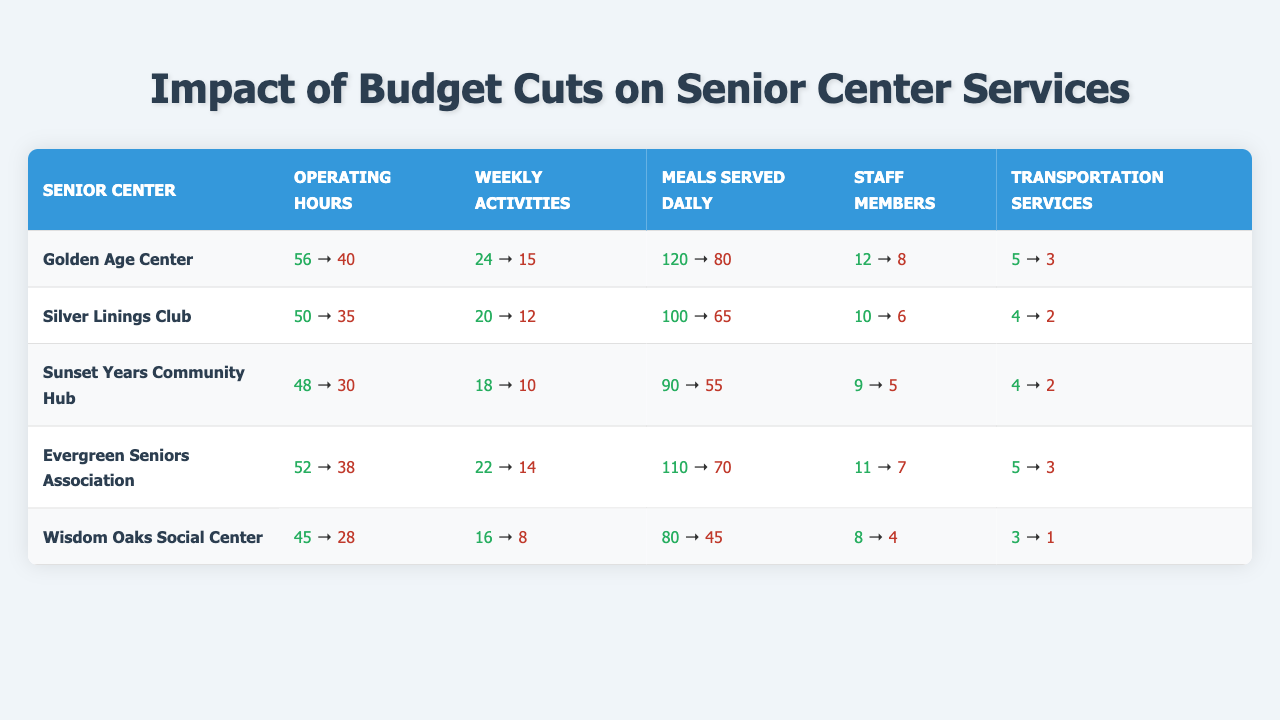What were the operating hours at the Golden Age Center before the budget cuts? The table lists the operating hours for the Golden Age Center as 56 hours before the budget cuts.
Answer: 56 How many meals were served daily at the Silver Linings Club after the budget cuts? According to the table, the number of meals served daily at the Silver Linings Club after the budget cuts is 65.
Answer: 65 What is the total reduction in weekly activities for the Sunset Years Community Hub due to budget cuts? Before the budget cuts, the Sunset Years Community Hub had 18 weekly activities, and after the cuts, it has 10. The reduction is calculated as 18 - 10 = 8.
Answer: 8 Did Evergreen Seniors Association serve more meals daily before or after the budget cuts? The Evergreen Seniors Association served 110 meals daily before the budget cuts and 70 meals after. Since 110 is greater than 70, they served more meals before the cuts.
Answer: Yes What are the differences in staff members before and after the budget cuts across all senior centers? For each center, we can find the difference: Golden Age Center (12 - 8 = 4), Silver Linings Club (10 - 6 = 4), Sunset Years Community Hub (9 - 5 = 4), Evergreen Seniors Association (11 - 7 = 4), and Wisdom Oaks Social Center (8 - 4 = 4). All Centers had a reduction of 4 staff members.
Answer: 4 Which senior center had the lowest operating hours after the budget cuts, and what were those hours? After the budget cuts, Wisdom Oaks Social Center had the lowest operating hours of 28.
Answer: Wisdom Oaks Social Center, 28 What is the overall average operating hours of all senior centers before the budget cuts? The total operating hours before cuts is (56 + 50 + 48 + 52 + 45) = 251, and there are 5 centers, so the average is 251 / 5 = 50.2.
Answer: 50.2 Which senior center experienced the highest percentage drop in transportation services after the budget cuts? Transportation services before and after cuts: Golden Age Center (5 to 3, 40% drop), Silver Linings Club (4 to 2, 50% drop), Sunset Years Community Hub (4 to 2, 50% drop), Evergreen Seniors Association (5 to 3, 40% drop), and Wisdom Oaks Social Center (3 to 1, 66.67% drop). The highest percentage drop is for Wisdom Oaks Social Center.
Answer: Wisdom Oaks Social Center What is the total number of meals served daily across all centers before budget cuts compared to after? Before budget cuts, total meals served daily is 120 + 100 + 90 + 110 + 80 = 500. After the cuts, total meals served daily is 80 + 65 + 55 + 70 + 45 = 315. The reduction in total meals served daily is 500 - 315 = 185.
Answer: 185 Are there any centers that retained the same number of transportation services before and after budget cuts? By checking the data: Golden Age Center (5 to 3), Silver Linings Club (4 to 2), Sunset Years Community Hub (4 to 2), Evergreen Seniors Association (5 to 3), Wisdom Oaks Social Center (3 to 1). None of them retained the same number.
Answer: No 